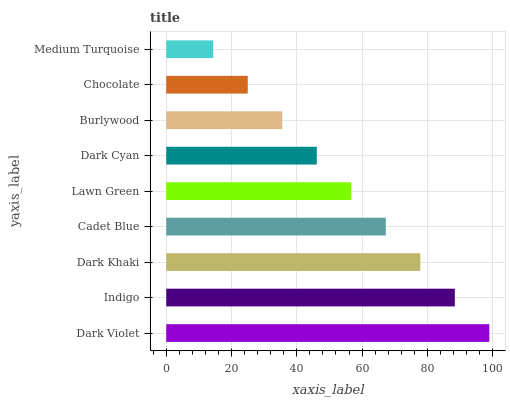Is Medium Turquoise the minimum?
Answer yes or no. Yes. Is Dark Violet the maximum?
Answer yes or no. Yes. Is Indigo the minimum?
Answer yes or no. No. Is Indigo the maximum?
Answer yes or no. No. Is Dark Violet greater than Indigo?
Answer yes or no. Yes. Is Indigo less than Dark Violet?
Answer yes or no. Yes. Is Indigo greater than Dark Violet?
Answer yes or no. No. Is Dark Violet less than Indigo?
Answer yes or no. No. Is Lawn Green the high median?
Answer yes or no. Yes. Is Lawn Green the low median?
Answer yes or no. Yes. Is Dark Cyan the high median?
Answer yes or no. No. Is Dark Violet the low median?
Answer yes or no. No. 